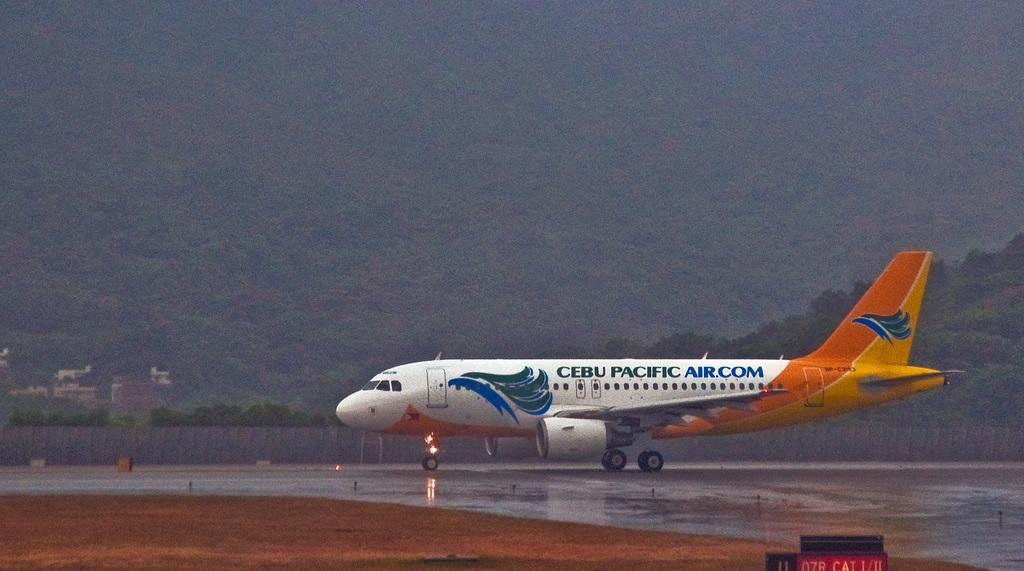<image>
Create a compact narrative representing the image presented. CEBU Pacific airplane that is sitting on the runway at an airport on an overcast day. 